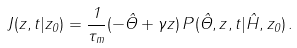<formula> <loc_0><loc_0><loc_500><loc_500>J ( z , t | z _ { 0 } ) = \frac { 1 } { \tau _ { m } } ( - \hat { \Theta } + \gamma z ) \, P ( \hat { \Theta } , z , t | \hat { H } , z _ { 0 } ) \, .</formula> 